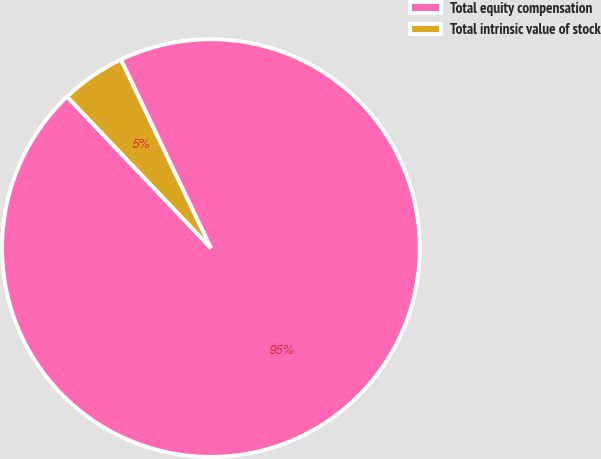Convert chart. <chart><loc_0><loc_0><loc_500><loc_500><pie_chart><fcel>Total equity compensation<fcel>Total intrinsic value of stock<nl><fcel>95.0%<fcel>5.0%<nl></chart> 